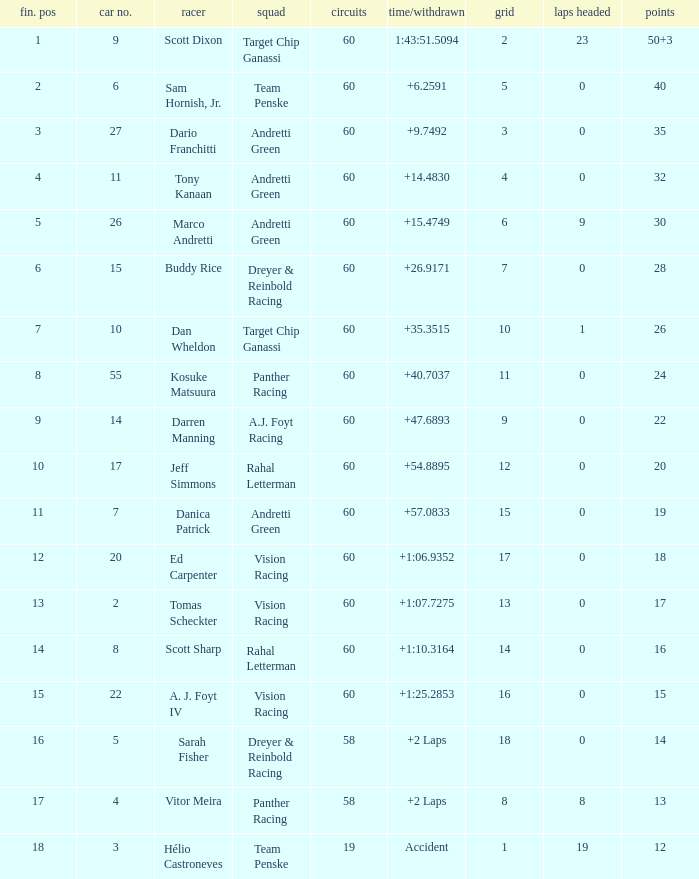Name the team for scott dixon Target Chip Ganassi. 